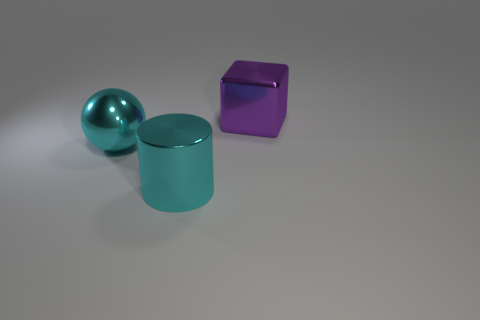What number of other things are there of the same color as the cylinder?
Make the answer very short. 1. Are there fewer purple objects left of the big metallic cylinder than cyan shiny cylinders to the left of the cube?
Offer a terse response. Yes. Is the shiny ball the same color as the metal cylinder?
Offer a terse response. Yes. What shape is the large cyan thing that is the same material as the cyan ball?
Keep it short and to the point. Cylinder. How many other big metallic things have the same shape as the purple metallic thing?
Make the answer very short. 0. There is a cyan thing left of the cyan object right of the cyan metallic ball; what shape is it?
Keep it short and to the point. Sphere. Do the purple metal thing on the right side of the sphere and the large ball have the same size?
Provide a succinct answer. Yes. There is a metal object that is both behind the large cyan shiny cylinder and on the left side of the purple metallic object; how big is it?
Ensure brevity in your answer.  Large. What number of other cylinders are the same size as the metal cylinder?
Provide a succinct answer. 0. There is a large shiny object behind the cyan ball; how many big cyan shiny cylinders are in front of it?
Your answer should be very brief. 1. 